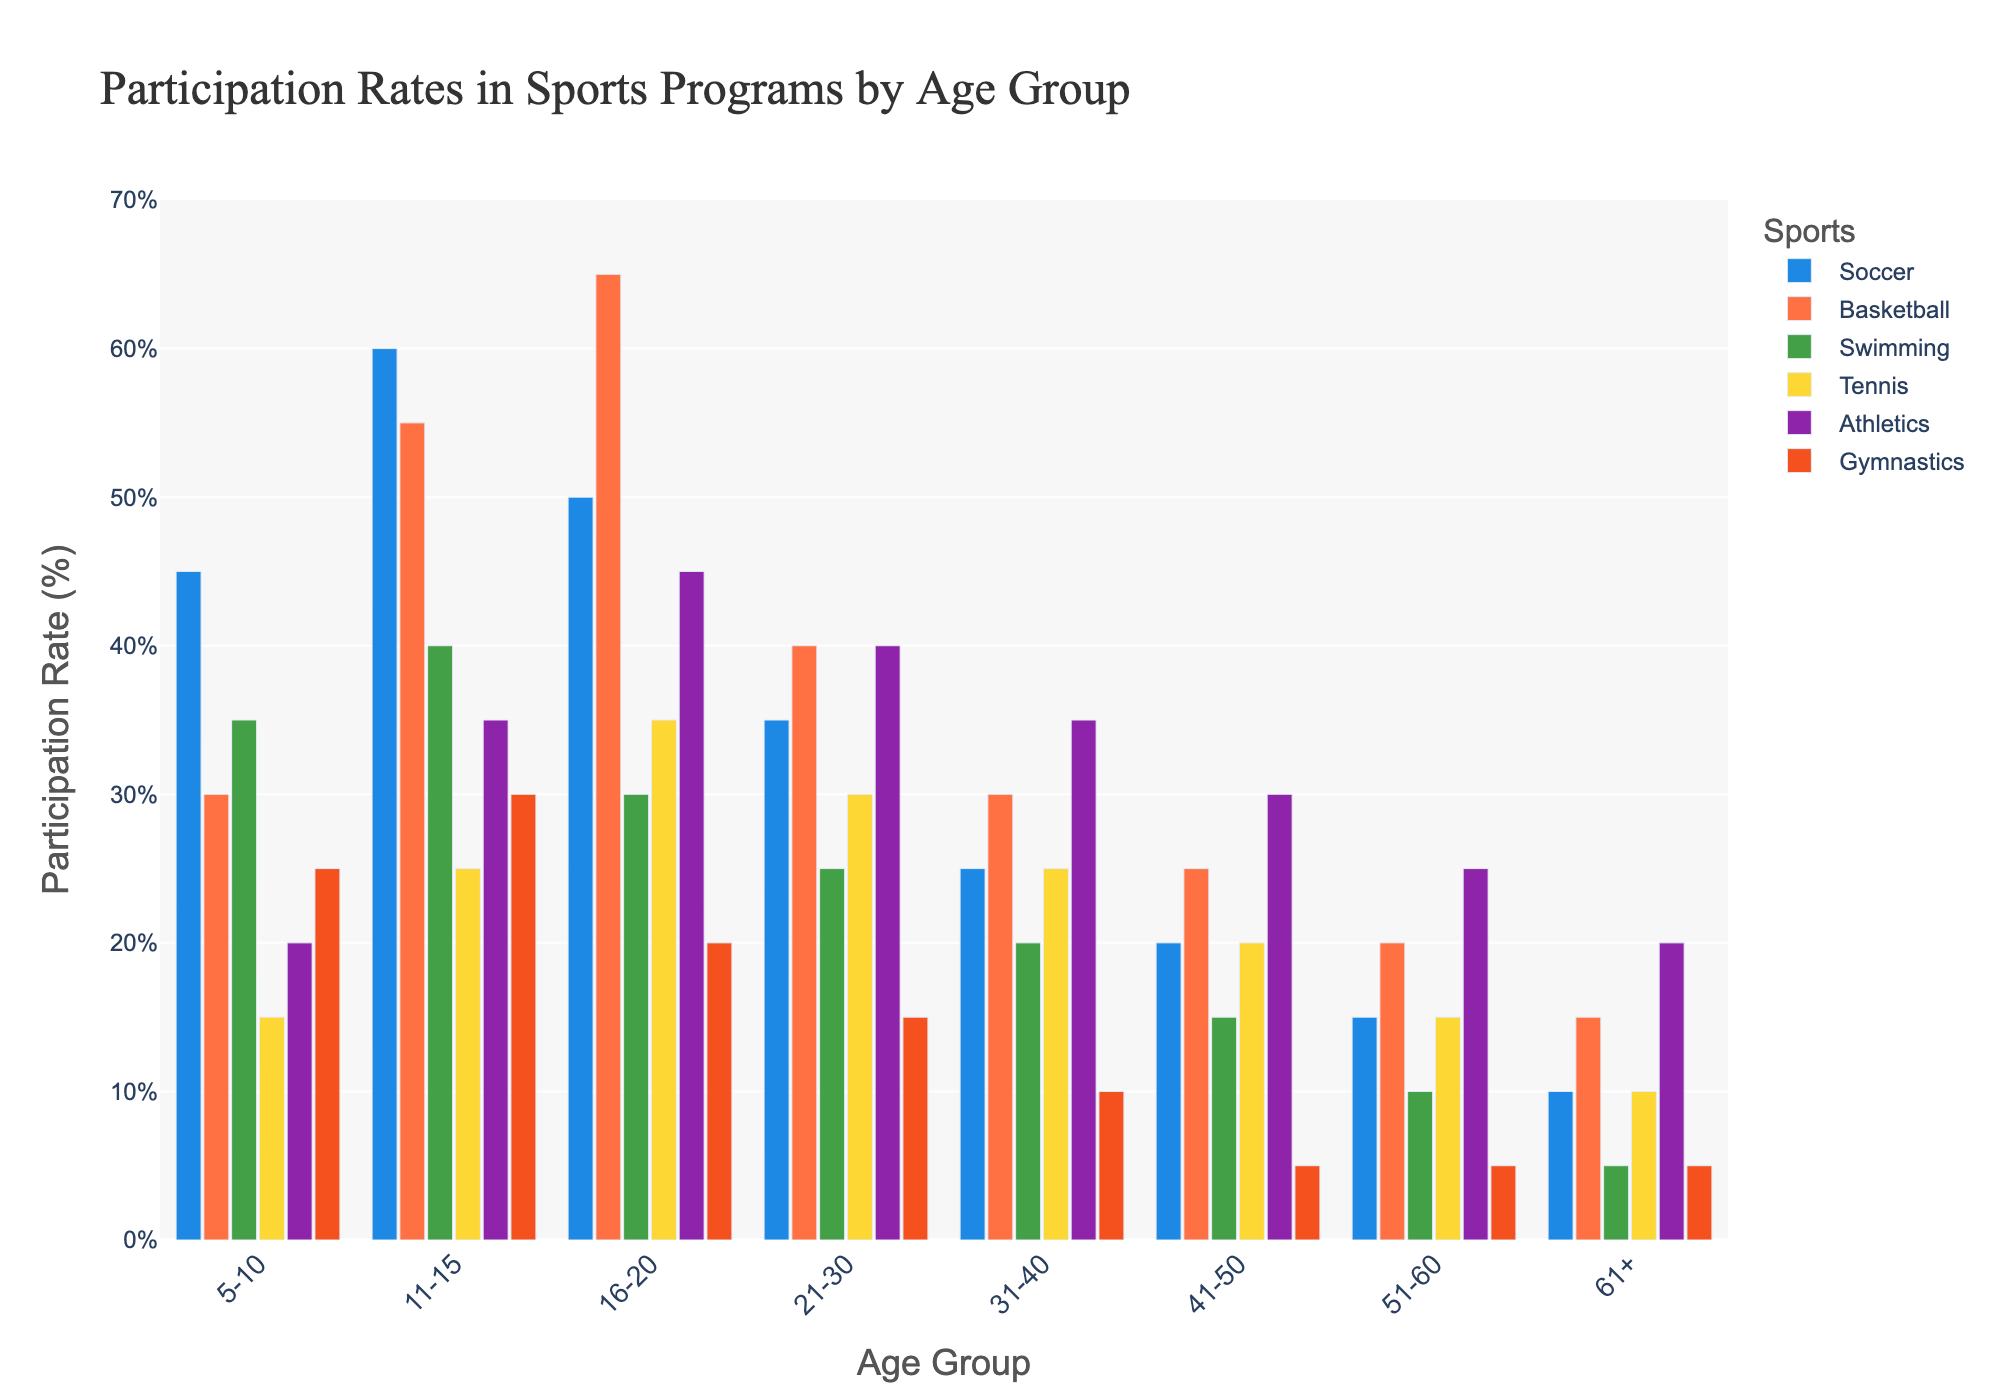Which age group has the highest participation rate in Basketball? Look at the Basketball bars for each age group and find the one with the greatest height. The highest bar is for the age group 16-20.
Answer: 16-20 What is the total participation rate for Gymnastics across all age groups? Add the values of Gymnastics participation for all age groups: 25 + 30 + 20 + 15 + 10 + 5 + 5 + 5 = 115.
Answer: 115% Which sport has the lowest participation rate for the 21-30 age group? Compare the height of the bars for the age group 21-30, and find the shortest bar. Gymnastics has the lowest participation rate (15).
Answer: Gymnastics Which age group has a higher participation rate in Swimming: 31-40 or 51-60? Compare the heights of the Swimming bars for the age groups 31-40 (20) and 51-60 (10). The Swimming participation rate is higher for 31-40.
Answer: 31-40 What is the average participation rate in Soccer for all age groups? Calculate the average by adding the Soccer participation rates and dividing by the number of groups: (45 + 60 + 50 + 35 + 25 + 20 + 15 + 10) / 8 = 32.5.
Answer: 32.5% Which sport has the most equal distribution of participation rates across all age groups? Assess the variation in heights of bars for each sport. Swimming has the most even distribution, with less fluctuation compared to other sports.
Answer: Swimming What is the range of participation rates for Athletics? Find the highest and lowest values in Athletics participation: the highest is 45 (16-20), and the lowest is 20 (61+), so the range is 45 - 20 = 25.
Answer: 25 How does the participation rate for Tennis compare between the 5-10 and 16-20 age groups? Compare the heights of the Tennis bars for these age groups. 5-10 has 15, while 16-20 has 35, making 16-20 higher by 20.
Answer: 16-20 is higher by 20 What is the participation rate for Soccer in the 41-50 age group, and how does it compare to the participation rate for Basketball in the same age group? Soccer has a rate of 20, and Basketball has a rate of 25. Basketball has a higher participation rate than Soccer by 5.
Answer: Basketball is higher by 5 In which age group is the participation rate in Tennis equal to the participation rate in Gymnastics? Compare the Tennis and Gymnastics bars across age groups. The participation rates are both 5 for the age group 61+.
Answer: 61+ 